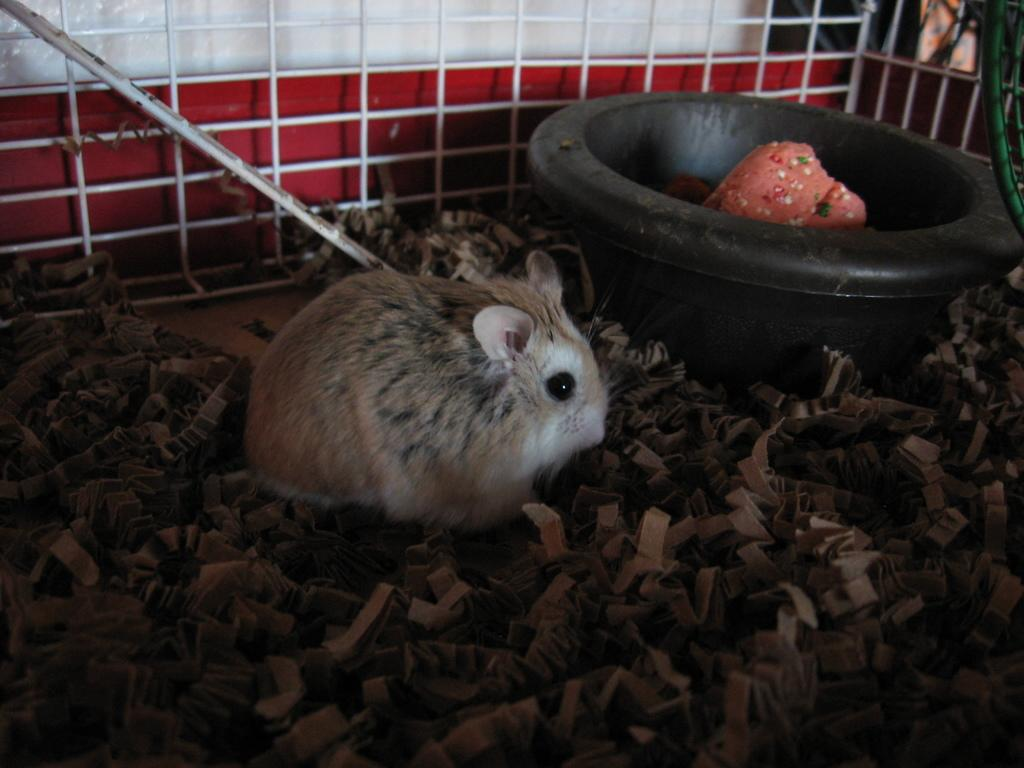What animal is present in the image? There is a rabbit in the image. What type of objects can be seen on the pieces of paper? The pieces of paper are not described in detail, so we cannot determine what type of objects are on them. What is inside the tub in the image? The tub has objects in it, but the specific objects are not described. What structures are visible in the background of the image? There is a pole, a fence, and a wall in the background of the image. What type of juice is being squeezed from the man in the image? There is no man or juice present in the image; it features a rabbit, pieces of paper, a tub, and structures in the background. 